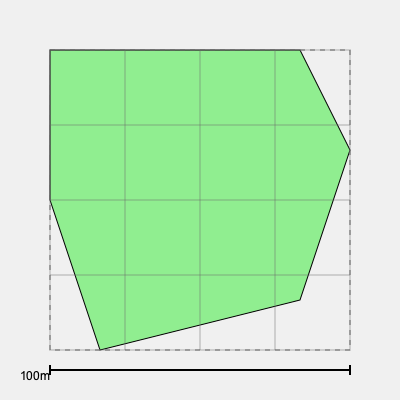As a government official consulting a retired urban planner, you're presented with a grid overlay of an irregularly shaped park. Each square in the grid represents 625 square meters. Estimate the total area of the park in hectares, rounding to the nearest tenth. To estimate the area of the irregularly shaped park using the grid overlay:

1. Count the number of full squares within the park boundaries:
   - There are approximately 16 full squares.

2. Count the number of partial squares:
   - There are approximately 14 partial squares.

3. Estimate the total number of squares:
   - Full squares: 16
   - Partial squares: 14 × 0.5 (assuming each partial square is, on average, half filled)
   - Total estimated squares: $16 + (14 × 0.5) = 16 + 7 = 23$

4. Calculate the total area:
   - Each square represents 625 m²
   - Total area = $23 × 625 \text{ m}² = 14,375 \text{ m}²$

5. Convert to hectares:
   - 1 hectare = 10,000 m²
   - Area in hectares = $14,375 \text{ m}² ÷ 10,000 \text{ m}²/\text{ha} = 1.4375 \text{ ha}$

6. Round to the nearest tenth:
   - $1.4375 \text{ ha} ≈ 1.4 \text{ ha}$

Therefore, the estimated area of the park is approximately 1.4 hectares.
Answer: 1.4 ha 